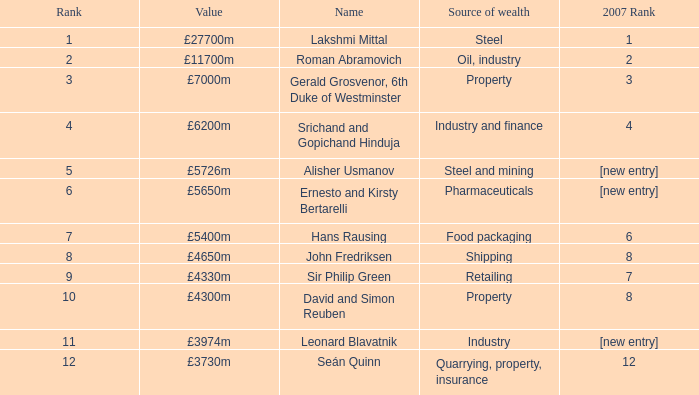What source of wealth has a value of £5726m? Steel and mining. 